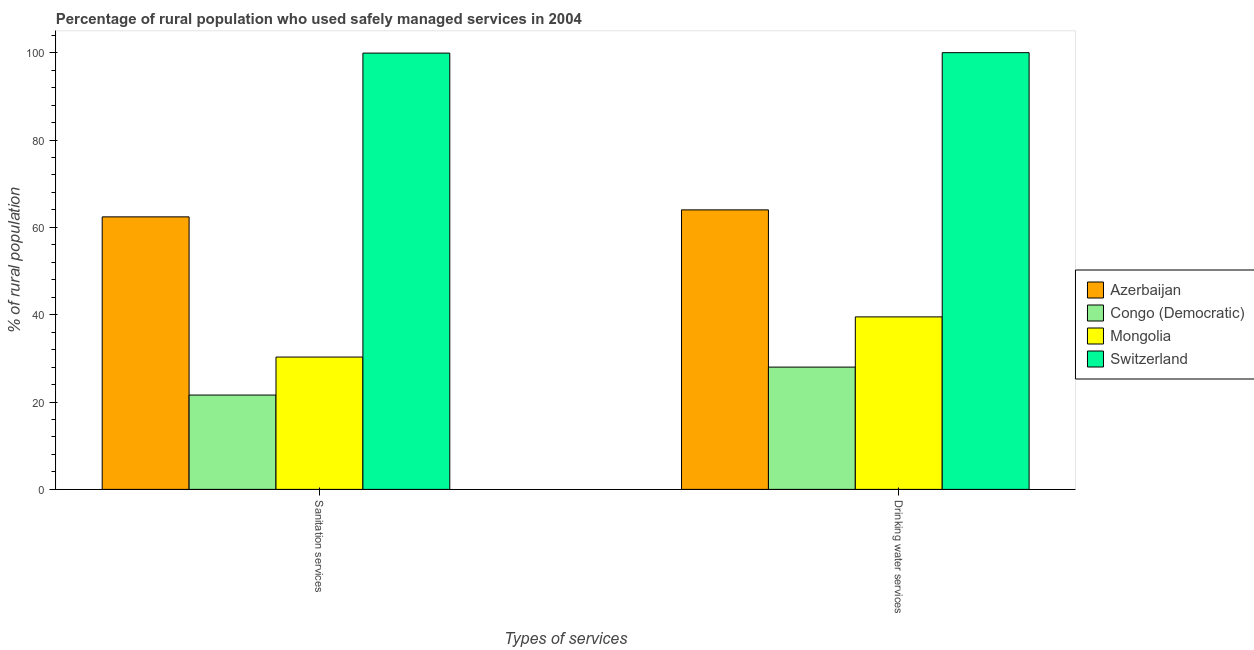How many different coloured bars are there?
Your answer should be very brief. 4. How many groups of bars are there?
Give a very brief answer. 2. Are the number of bars on each tick of the X-axis equal?
Offer a very short reply. Yes. How many bars are there on the 1st tick from the left?
Offer a terse response. 4. How many bars are there on the 1st tick from the right?
Offer a very short reply. 4. What is the label of the 1st group of bars from the left?
Ensure brevity in your answer.  Sanitation services. What is the percentage of rural population who used drinking water services in Mongolia?
Your response must be concise. 39.5. Across all countries, what is the maximum percentage of rural population who used sanitation services?
Your response must be concise. 99.9. In which country was the percentage of rural population who used drinking water services maximum?
Offer a very short reply. Switzerland. In which country was the percentage of rural population who used drinking water services minimum?
Provide a short and direct response. Congo (Democratic). What is the total percentage of rural population who used drinking water services in the graph?
Make the answer very short. 231.5. What is the difference between the percentage of rural population who used drinking water services in Switzerland and the percentage of rural population who used sanitation services in Congo (Democratic)?
Offer a terse response. 78.4. What is the average percentage of rural population who used sanitation services per country?
Ensure brevity in your answer.  53.55. What is the difference between the percentage of rural population who used drinking water services and percentage of rural population who used sanitation services in Azerbaijan?
Offer a terse response. 1.6. What is the ratio of the percentage of rural population who used drinking water services in Azerbaijan to that in Mongolia?
Offer a very short reply. 1.62. Is the percentage of rural population who used sanitation services in Azerbaijan less than that in Switzerland?
Provide a succinct answer. Yes. In how many countries, is the percentage of rural population who used drinking water services greater than the average percentage of rural population who used drinking water services taken over all countries?
Keep it short and to the point. 2. What does the 2nd bar from the left in Sanitation services represents?
Your response must be concise. Congo (Democratic). What does the 2nd bar from the right in Drinking water services represents?
Give a very brief answer. Mongolia. Are all the bars in the graph horizontal?
Keep it short and to the point. No. How many countries are there in the graph?
Give a very brief answer. 4. Are the values on the major ticks of Y-axis written in scientific E-notation?
Your answer should be very brief. No. Does the graph contain grids?
Provide a short and direct response. No. Where does the legend appear in the graph?
Offer a terse response. Center right. What is the title of the graph?
Your answer should be compact. Percentage of rural population who used safely managed services in 2004. What is the label or title of the X-axis?
Offer a very short reply. Types of services. What is the label or title of the Y-axis?
Your answer should be very brief. % of rural population. What is the % of rural population of Azerbaijan in Sanitation services?
Keep it short and to the point. 62.4. What is the % of rural population in Congo (Democratic) in Sanitation services?
Your answer should be compact. 21.6. What is the % of rural population in Mongolia in Sanitation services?
Keep it short and to the point. 30.3. What is the % of rural population in Switzerland in Sanitation services?
Give a very brief answer. 99.9. What is the % of rural population of Congo (Democratic) in Drinking water services?
Ensure brevity in your answer.  28. What is the % of rural population in Mongolia in Drinking water services?
Keep it short and to the point. 39.5. Across all Types of services, what is the maximum % of rural population of Azerbaijan?
Ensure brevity in your answer.  64. Across all Types of services, what is the maximum % of rural population of Congo (Democratic)?
Offer a very short reply. 28. Across all Types of services, what is the maximum % of rural population in Mongolia?
Offer a very short reply. 39.5. Across all Types of services, what is the maximum % of rural population in Switzerland?
Provide a succinct answer. 100. Across all Types of services, what is the minimum % of rural population in Azerbaijan?
Give a very brief answer. 62.4. Across all Types of services, what is the minimum % of rural population of Congo (Democratic)?
Ensure brevity in your answer.  21.6. Across all Types of services, what is the minimum % of rural population of Mongolia?
Offer a very short reply. 30.3. Across all Types of services, what is the minimum % of rural population of Switzerland?
Ensure brevity in your answer.  99.9. What is the total % of rural population of Azerbaijan in the graph?
Offer a terse response. 126.4. What is the total % of rural population of Congo (Democratic) in the graph?
Give a very brief answer. 49.6. What is the total % of rural population of Mongolia in the graph?
Offer a terse response. 69.8. What is the total % of rural population in Switzerland in the graph?
Provide a succinct answer. 199.9. What is the difference between the % of rural population of Azerbaijan in Sanitation services and that in Drinking water services?
Provide a succinct answer. -1.6. What is the difference between the % of rural population in Azerbaijan in Sanitation services and the % of rural population in Congo (Democratic) in Drinking water services?
Your answer should be compact. 34.4. What is the difference between the % of rural population of Azerbaijan in Sanitation services and the % of rural population of Mongolia in Drinking water services?
Make the answer very short. 22.9. What is the difference between the % of rural population in Azerbaijan in Sanitation services and the % of rural population in Switzerland in Drinking water services?
Ensure brevity in your answer.  -37.6. What is the difference between the % of rural population in Congo (Democratic) in Sanitation services and the % of rural population in Mongolia in Drinking water services?
Ensure brevity in your answer.  -17.9. What is the difference between the % of rural population in Congo (Democratic) in Sanitation services and the % of rural population in Switzerland in Drinking water services?
Keep it short and to the point. -78.4. What is the difference between the % of rural population of Mongolia in Sanitation services and the % of rural population of Switzerland in Drinking water services?
Keep it short and to the point. -69.7. What is the average % of rural population of Azerbaijan per Types of services?
Your response must be concise. 63.2. What is the average % of rural population in Congo (Democratic) per Types of services?
Offer a very short reply. 24.8. What is the average % of rural population in Mongolia per Types of services?
Your answer should be very brief. 34.9. What is the average % of rural population in Switzerland per Types of services?
Offer a terse response. 99.95. What is the difference between the % of rural population in Azerbaijan and % of rural population in Congo (Democratic) in Sanitation services?
Your answer should be very brief. 40.8. What is the difference between the % of rural population of Azerbaijan and % of rural population of Mongolia in Sanitation services?
Offer a terse response. 32.1. What is the difference between the % of rural population in Azerbaijan and % of rural population in Switzerland in Sanitation services?
Ensure brevity in your answer.  -37.5. What is the difference between the % of rural population of Congo (Democratic) and % of rural population of Mongolia in Sanitation services?
Your answer should be very brief. -8.7. What is the difference between the % of rural population in Congo (Democratic) and % of rural population in Switzerland in Sanitation services?
Your answer should be very brief. -78.3. What is the difference between the % of rural population of Mongolia and % of rural population of Switzerland in Sanitation services?
Provide a short and direct response. -69.6. What is the difference between the % of rural population in Azerbaijan and % of rural population in Switzerland in Drinking water services?
Offer a terse response. -36. What is the difference between the % of rural population in Congo (Democratic) and % of rural population in Switzerland in Drinking water services?
Provide a short and direct response. -72. What is the difference between the % of rural population in Mongolia and % of rural population in Switzerland in Drinking water services?
Offer a very short reply. -60.5. What is the ratio of the % of rural population in Azerbaijan in Sanitation services to that in Drinking water services?
Keep it short and to the point. 0.97. What is the ratio of the % of rural population in Congo (Democratic) in Sanitation services to that in Drinking water services?
Your answer should be compact. 0.77. What is the ratio of the % of rural population of Mongolia in Sanitation services to that in Drinking water services?
Give a very brief answer. 0.77. What is the ratio of the % of rural population of Switzerland in Sanitation services to that in Drinking water services?
Your answer should be compact. 1. What is the difference between the highest and the second highest % of rural population in Switzerland?
Provide a short and direct response. 0.1. What is the difference between the highest and the lowest % of rural population of Mongolia?
Provide a succinct answer. 9.2. What is the difference between the highest and the lowest % of rural population in Switzerland?
Your answer should be compact. 0.1. 